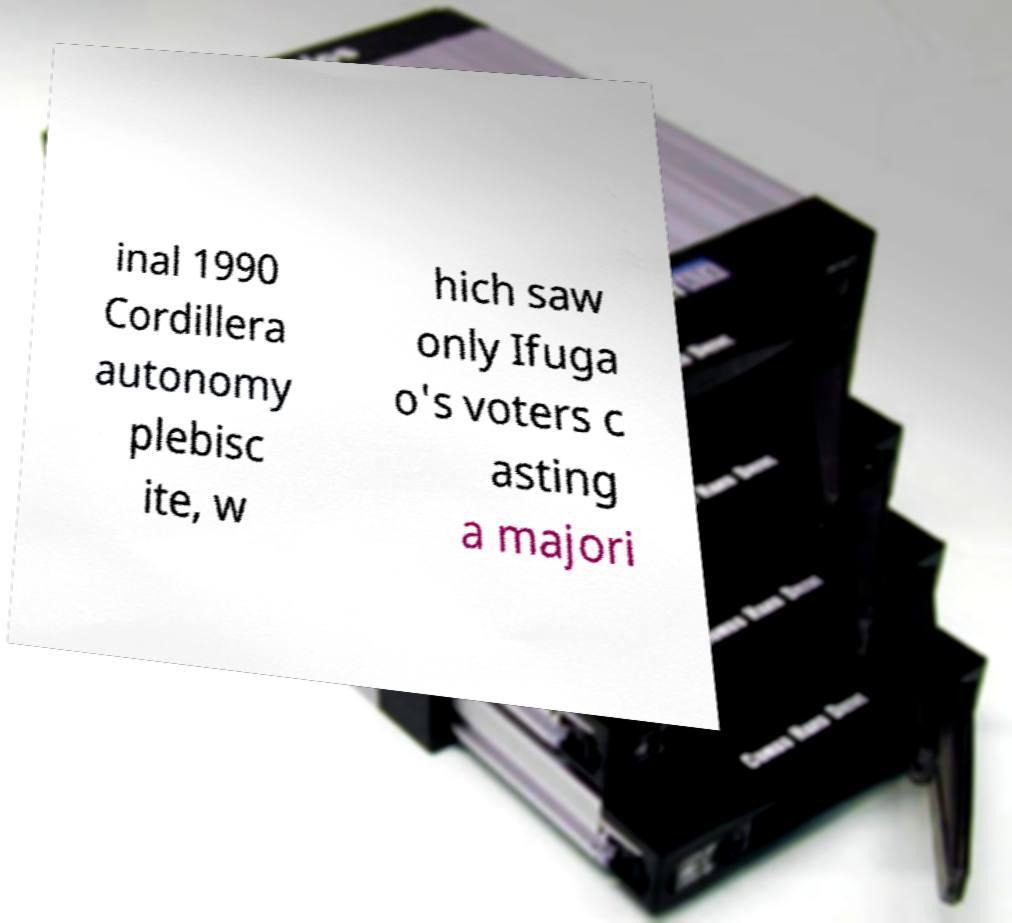For documentation purposes, I need the text within this image transcribed. Could you provide that? inal 1990 Cordillera autonomy plebisc ite, w hich saw only Ifuga o's voters c asting a majori 